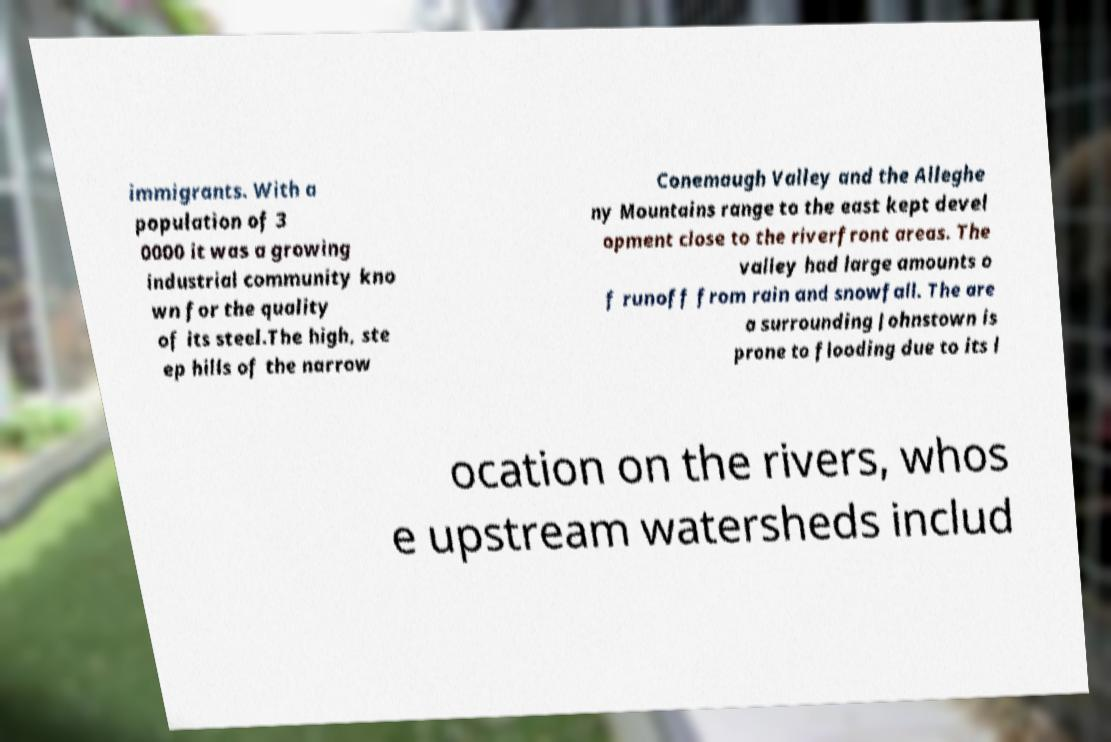What messages or text are displayed in this image? I need them in a readable, typed format. immigrants. With a population of 3 0000 it was a growing industrial community kno wn for the quality of its steel.The high, ste ep hills of the narrow Conemaugh Valley and the Alleghe ny Mountains range to the east kept devel opment close to the riverfront areas. The valley had large amounts o f runoff from rain and snowfall. The are a surrounding Johnstown is prone to flooding due to its l ocation on the rivers, whos e upstream watersheds includ 